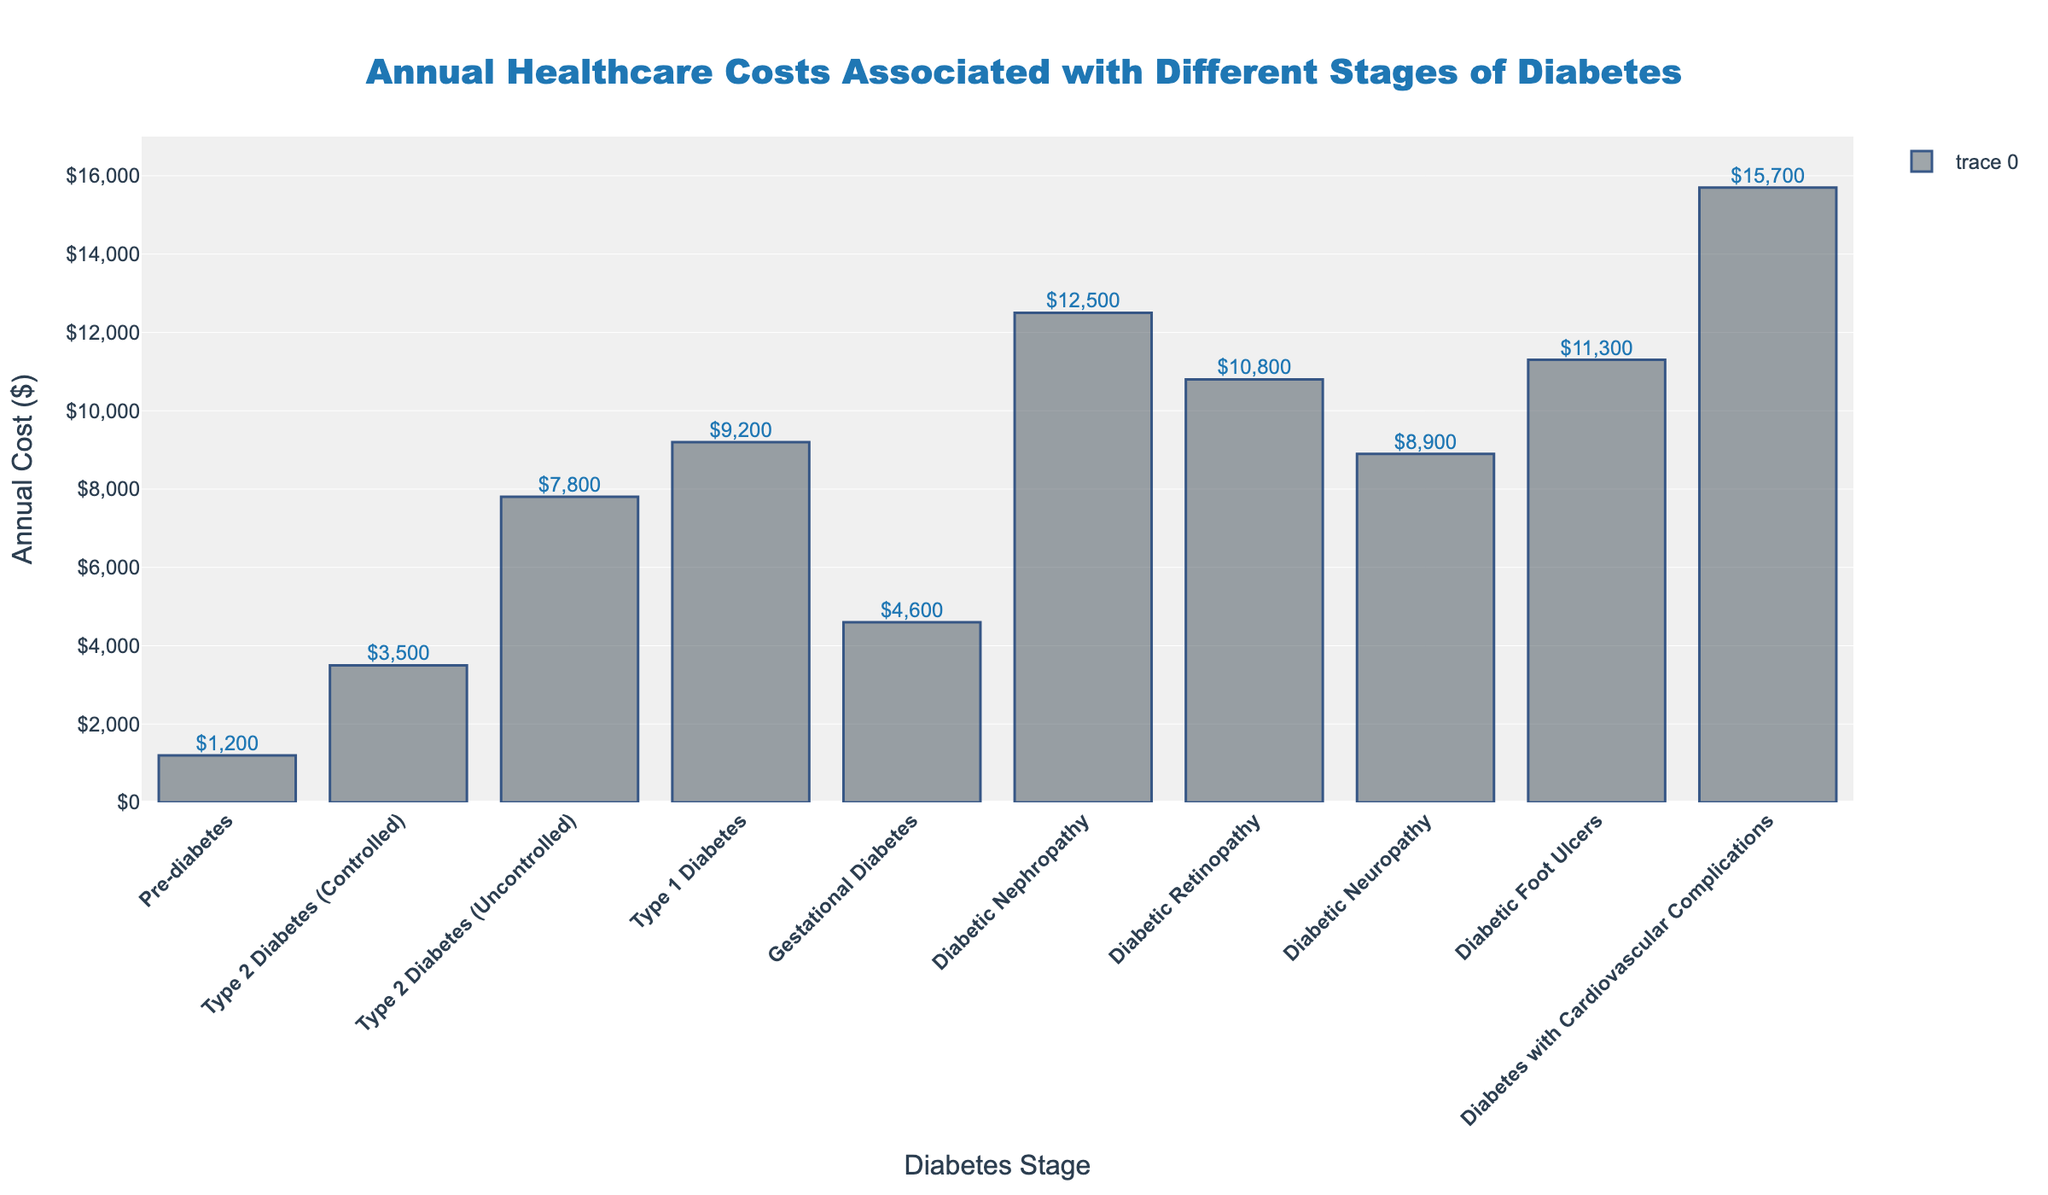Which diabetes stage has the highest annual healthcare cost? To find the highest annual healthcare cost, observe the highest bar. "Diabetes with Cardiovascular Complications" has the highest bar at $15,700.
Answer: Diabetes with Cardiovascular Complications Which stage has the lowest annual cost associated with diabetes? Locate the shortest bar. "Pre-diabetes" has the lowest annual cost at $1,200.
Answer: Pre-diabetes How much more does controlling Type 2 Diabetes cost compared to pre-diabetes annually? The cost for controlled Type 2 Diabetes is $3,500 and pre-diabetes is $1,200. Calculate the difference: $3,500 - $1,200 = $2,300
Answer: $2,300 Which costs more annually, Type 1 Diabetes or Diabetic Foot Ulcers? Compare the bars for Type 1 Diabetes and Diabetic Foot Ulcers. Type 1 Diabetes costs $9,200, and Diabetic Foot Ulcers cost $11,300. Since $11,300 > $9,200, Diabetic Foot Ulcers cost more.
Answer: Diabetic Foot Ulcers What is the difference in annual cost between Diabetic Neuropathy and Diabetic Retinopathy? Diabetic Neuropathy costs $8,900 annually, and Diabetic Retinopathy costs $10,800. Calculate the difference: $10,800 - $8,900 = $1,900
Answer: $1,900 What is the average annual cost associated with all listed diabetes stages? Add all annual costs and divide by the number of stages: ($1,200 + $3,500 + $7,800 + $9,200 + $4,600 + $12,500 + $10,800 + $8,900 + $11,300 + $15,700) / 10 = $85,500 / 10 = $8,550
Answer: $8,550 Which stage has a higher annual cost, Gestational Diabetes or Type 2 Diabetes (Uncontrolled)? Compare the bars for Gestational Diabetes and Type 2 Diabetes (Uncontrolled). Gestational Diabetes costs $4,600, and Type 2 Diabetes (Uncontrolled) costs $7,800. Since $7,800 > $4,600, Type 2 Diabetes (Uncontrolled) has a higher cost.
Answer: Type 2 Diabetes (Uncontrolled) What is the combined annual cost of Diabetic Nephropathy and Diabetes with Cardiovascular Complications? Add the annual costs: $12,500 (Diabetic Nephropathy) + $15,700 (Diabetes with Cardiovascular Complications) = $28,200
Answer: $28,200 What's the percentage increase in annual cost from Type 2 Diabetes (Controlled) to Type 2 Diabetes (Uncontrolled)? Calculate the difference and then the percentage: $7,800 - $3,500 = $4,300. Then, ($4,300 / $3,500) * 100 = 122.86%
Answer: 122.86% 